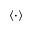<formula> <loc_0><loc_0><loc_500><loc_500>\left < \cdot \right ></formula> 